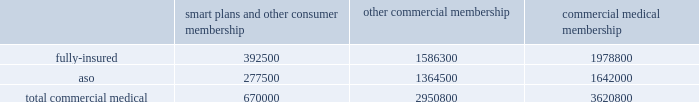Va health care delivery system through our network of providers .
We are compensated by the va for the cost of our providers 2019 services at a specified contractual amount per service plus an additional administrative fee for each transaction .
The contract , under which we began providing services on january 1 , 2008 , is comprised of one base period and four one-year option periods subject to renewals at the federal government 2019s option .
We are currently in the first option period , which expires on september 30 , 2009 .
For the year ended december 31 , 2008 , revenues under this va contract were approximately $ 22.7 million , or less than 1% ( 1 % ) of our total premium and aso fees .
For the year ended december 31 , 2008 , military services premium revenues were approximately $ 3.2 billion , or 11.3% ( 11.3 % ) of our total premiums and aso fees , and military services aso fees totaled $ 76.8 million , or 0.3% ( 0.3 % ) of our total premiums and aso fees .
International and green ribbon health operations in august 2006 , we established our subsidiary humana europe in the united kingdom to provide commissioning support to primary care trusts , or pcts , in england .
Under the contracts we are awarded , we work in partnership with local pcts , health care providers , and patients to strengthen health-service delivery and to implement strategies at a local level to help the national health service enhance patient experience , improve clinical outcomes , and reduce costs .
For the year ended december 31 , 2008 , revenues under these contracts were approximately $ 7.7 million , or less than 1% ( 1 % ) of our total premium and aso fees .
We participated in a medicare health support pilot program through green ribbon health , or grh , a joint- venture company with pfizer health solutions inc .
Grh was designed to support cms assigned medicare beneficiaries living with diabetes and/or congestive heart failure in central florida .
Grh used disease management initiatives , including evidence-based clinical guidelines , personal self-directed change strategies , and personal nurses to help participants navigate the health system .
Revenues under the contract with cms over the period which began november 1 , 2005 and ended august 15 , 2008 are subject to refund unless savings , satisfaction , and clinical improvement targets are met .
Under the terms of the contract , after a claims run-out period , cms is required to deliver a performance report during the third quarter of 2009 .
To date , all revenues have been deferred until reliable estimates are determinable , and revenues are not expected to be material when recognized .
Our products marketed to commercial segment employers and members smart plans and other consumer products over the last several years , we have developed and offered various commercial products designed to provide options and choices to employers that are annually facing substantial premium increases driven by double-digit medical cost inflation .
These smart plans , discussed more fully below , and other consumer offerings , which can be offered on either a fully-insured or aso basis , provided coverage to approximately 670000 members at december 31 , 2008 , representing approximately 18.5% ( 18.5 % ) of our total commercial medical membership as detailed below .
Smart plans and other consumer membership other commercial membership commercial medical membership .
These products are often offered to employer groups as 201cbundles 201d , where the subscribers are offered various hmo and ppo options , with various employer contribution strategies as determined by the employer. .
What is the percentage of fully-insured memberships among the total commercial medical membership? 
Rationale: it is the number of fully-insured memberships divided by the total number of memberships , then turned into a percentage .
Computations: (1978800 / 3620800)
Answer: 0.54651. Va health care delivery system through our network of providers .
We are compensated by the va for the cost of our providers 2019 services at a specified contractual amount per service plus an additional administrative fee for each transaction .
The contract , under which we began providing services on january 1 , 2008 , is comprised of one base period and four one-year option periods subject to renewals at the federal government 2019s option .
We are currently in the first option period , which expires on september 30 , 2009 .
For the year ended december 31 , 2008 , revenues under this va contract were approximately $ 22.7 million , or less than 1% ( 1 % ) of our total premium and aso fees .
For the year ended december 31 , 2008 , military services premium revenues were approximately $ 3.2 billion , or 11.3% ( 11.3 % ) of our total premiums and aso fees , and military services aso fees totaled $ 76.8 million , or 0.3% ( 0.3 % ) of our total premiums and aso fees .
International and green ribbon health operations in august 2006 , we established our subsidiary humana europe in the united kingdom to provide commissioning support to primary care trusts , or pcts , in england .
Under the contracts we are awarded , we work in partnership with local pcts , health care providers , and patients to strengthen health-service delivery and to implement strategies at a local level to help the national health service enhance patient experience , improve clinical outcomes , and reduce costs .
For the year ended december 31 , 2008 , revenues under these contracts were approximately $ 7.7 million , or less than 1% ( 1 % ) of our total premium and aso fees .
We participated in a medicare health support pilot program through green ribbon health , or grh , a joint- venture company with pfizer health solutions inc .
Grh was designed to support cms assigned medicare beneficiaries living with diabetes and/or congestive heart failure in central florida .
Grh used disease management initiatives , including evidence-based clinical guidelines , personal self-directed change strategies , and personal nurses to help participants navigate the health system .
Revenues under the contract with cms over the period which began november 1 , 2005 and ended august 15 , 2008 are subject to refund unless savings , satisfaction , and clinical improvement targets are met .
Under the terms of the contract , after a claims run-out period , cms is required to deliver a performance report during the third quarter of 2009 .
To date , all revenues have been deferred until reliable estimates are determinable , and revenues are not expected to be material when recognized .
Our products marketed to commercial segment employers and members smart plans and other consumer products over the last several years , we have developed and offered various commercial products designed to provide options and choices to employers that are annually facing substantial premium increases driven by double-digit medical cost inflation .
These smart plans , discussed more fully below , and other consumer offerings , which can be offered on either a fully-insured or aso basis , provided coverage to approximately 670000 members at december 31 , 2008 , representing approximately 18.5% ( 18.5 % ) of our total commercial medical membership as detailed below .
Smart plans and other consumer membership other commercial membership commercial medical membership .
These products are often offered to employer groups as 201cbundles 201d , where the subscribers are offered various hmo and ppo options , with various employer contribution strategies as determined by the employer. .
At december 31 , 2008 what was the percent of the fully-insured to the total commercial medical smart plans and other consumer membership? 
Computations: (392500 / 670000)
Answer: 0.58582. 